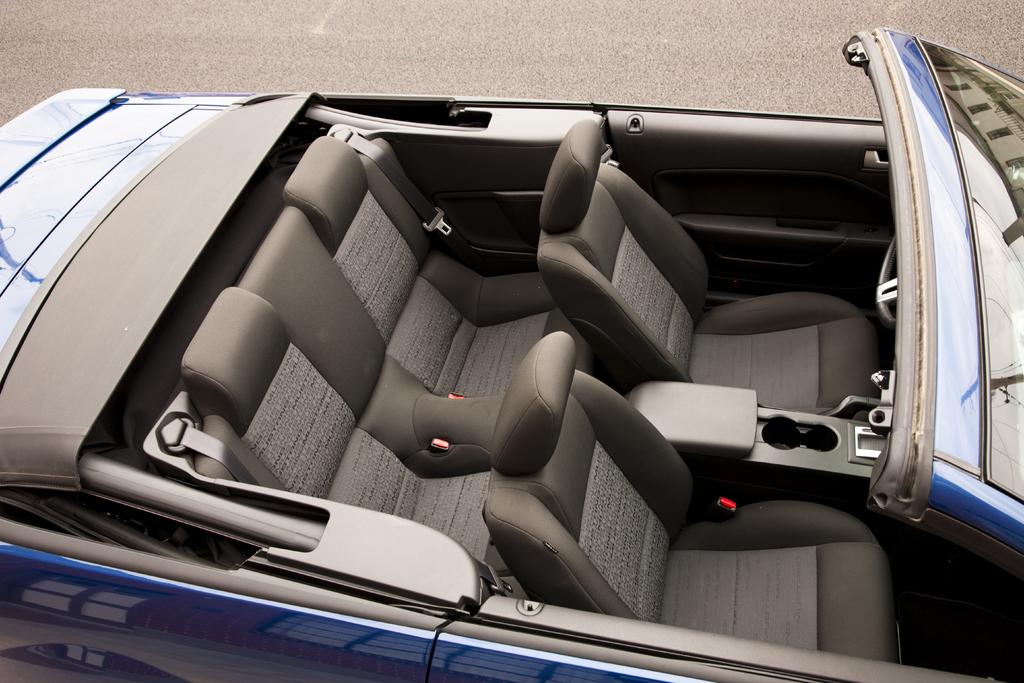What type of car is in the image? There is a blue color convertible car in the image. Where is the car located? The car is on the road. What type of star can be seen in the image? There is no star visible in the image; it features a blue color convertible car on the road. What kind of store is present in the image? There is no store present in the image; it only shows a blue color convertible car on the road. 